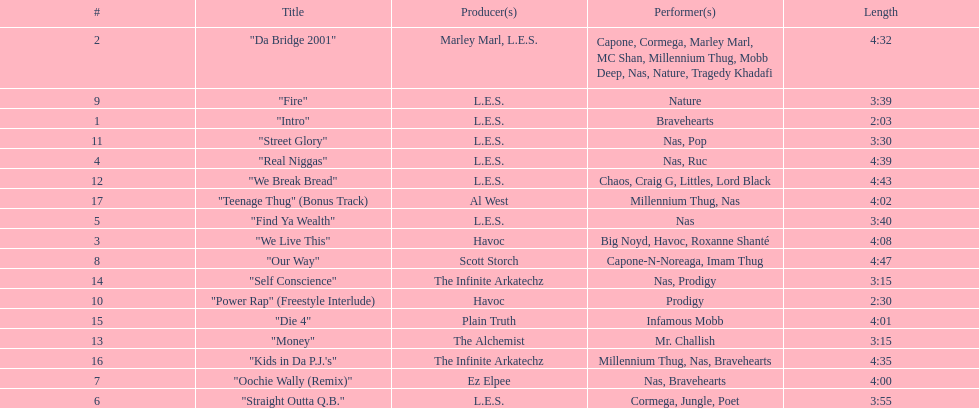How long is the longest track listed? 4:47. 